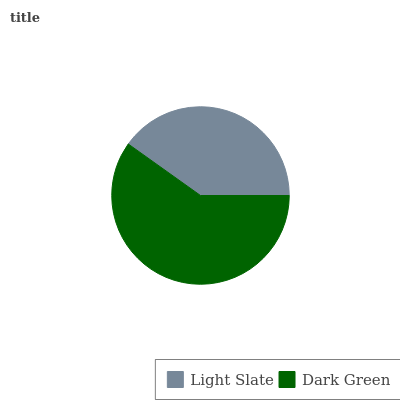Is Light Slate the minimum?
Answer yes or no. Yes. Is Dark Green the maximum?
Answer yes or no. Yes. Is Dark Green the minimum?
Answer yes or no. No. Is Dark Green greater than Light Slate?
Answer yes or no. Yes. Is Light Slate less than Dark Green?
Answer yes or no. Yes. Is Light Slate greater than Dark Green?
Answer yes or no. No. Is Dark Green less than Light Slate?
Answer yes or no. No. Is Dark Green the high median?
Answer yes or no. Yes. Is Light Slate the low median?
Answer yes or no. Yes. Is Light Slate the high median?
Answer yes or no. No. Is Dark Green the low median?
Answer yes or no. No. 